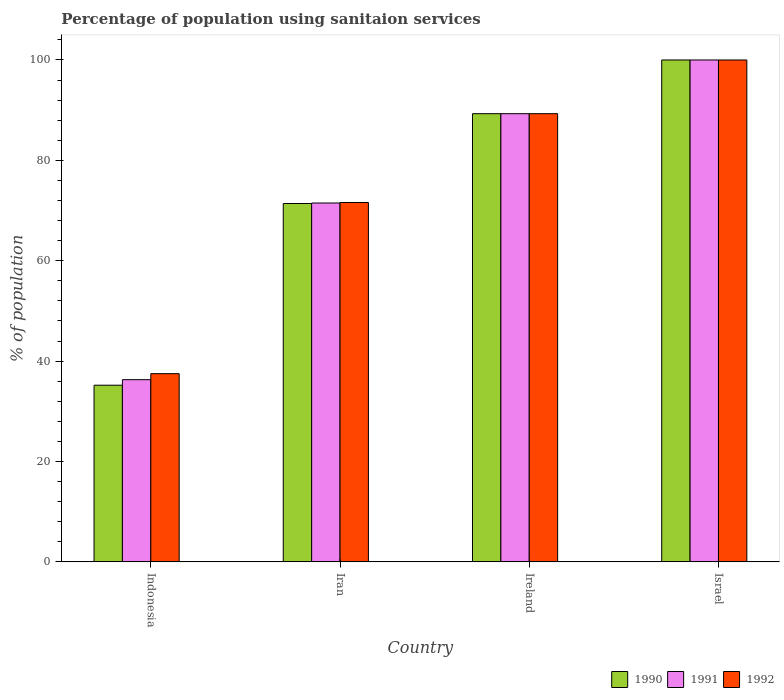How many groups of bars are there?
Offer a terse response. 4. Are the number of bars on each tick of the X-axis equal?
Keep it short and to the point. Yes. What is the label of the 3rd group of bars from the left?
Offer a very short reply. Ireland. What is the percentage of population using sanitaion services in 1992 in Iran?
Give a very brief answer. 71.6. Across all countries, what is the maximum percentage of population using sanitaion services in 1992?
Your answer should be very brief. 100. Across all countries, what is the minimum percentage of population using sanitaion services in 1991?
Provide a short and direct response. 36.3. In which country was the percentage of population using sanitaion services in 1990 minimum?
Provide a succinct answer. Indonesia. What is the total percentage of population using sanitaion services in 1990 in the graph?
Your response must be concise. 295.9. What is the difference between the percentage of population using sanitaion services in 1990 in Iran and that in Ireland?
Offer a terse response. -17.9. What is the difference between the percentage of population using sanitaion services in 1990 in Iran and the percentage of population using sanitaion services in 1991 in Israel?
Provide a short and direct response. -28.6. What is the average percentage of population using sanitaion services in 1992 per country?
Offer a terse response. 74.6. In how many countries, is the percentage of population using sanitaion services in 1992 greater than 36 %?
Offer a very short reply. 4. What is the ratio of the percentage of population using sanitaion services in 1991 in Ireland to that in Israel?
Provide a succinct answer. 0.89. Is the percentage of population using sanitaion services in 1991 in Ireland less than that in Israel?
Your answer should be compact. Yes. What is the difference between the highest and the second highest percentage of population using sanitaion services in 1992?
Your answer should be compact. -10.7. What is the difference between the highest and the lowest percentage of population using sanitaion services in 1992?
Make the answer very short. 62.5. Is the sum of the percentage of population using sanitaion services in 1990 in Indonesia and Israel greater than the maximum percentage of population using sanitaion services in 1992 across all countries?
Give a very brief answer. Yes. What does the 2nd bar from the left in Ireland represents?
Provide a short and direct response. 1991. What does the 3rd bar from the right in Iran represents?
Your response must be concise. 1990. How many bars are there?
Your answer should be very brief. 12. Are the values on the major ticks of Y-axis written in scientific E-notation?
Make the answer very short. No. Does the graph contain any zero values?
Provide a succinct answer. No. Does the graph contain grids?
Keep it short and to the point. No. Where does the legend appear in the graph?
Ensure brevity in your answer.  Bottom right. How many legend labels are there?
Make the answer very short. 3. What is the title of the graph?
Provide a short and direct response. Percentage of population using sanitaion services. What is the label or title of the Y-axis?
Give a very brief answer. % of population. What is the % of population of 1990 in Indonesia?
Keep it short and to the point. 35.2. What is the % of population in 1991 in Indonesia?
Provide a succinct answer. 36.3. What is the % of population of 1992 in Indonesia?
Provide a short and direct response. 37.5. What is the % of population of 1990 in Iran?
Your answer should be compact. 71.4. What is the % of population in 1991 in Iran?
Ensure brevity in your answer.  71.5. What is the % of population in 1992 in Iran?
Your response must be concise. 71.6. What is the % of population in 1990 in Ireland?
Offer a very short reply. 89.3. What is the % of population of 1991 in Ireland?
Make the answer very short. 89.3. What is the % of population of 1992 in Ireland?
Keep it short and to the point. 89.3. What is the % of population of 1992 in Israel?
Ensure brevity in your answer.  100. Across all countries, what is the minimum % of population in 1990?
Provide a short and direct response. 35.2. Across all countries, what is the minimum % of population in 1991?
Provide a short and direct response. 36.3. Across all countries, what is the minimum % of population of 1992?
Ensure brevity in your answer.  37.5. What is the total % of population of 1990 in the graph?
Your answer should be very brief. 295.9. What is the total % of population in 1991 in the graph?
Ensure brevity in your answer.  297.1. What is the total % of population in 1992 in the graph?
Give a very brief answer. 298.4. What is the difference between the % of population of 1990 in Indonesia and that in Iran?
Ensure brevity in your answer.  -36.2. What is the difference between the % of population in 1991 in Indonesia and that in Iran?
Make the answer very short. -35.2. What is the difference between the % of population in 1992 in Indonesia and that in Iran?
Your answer should be compact. -34.1. What is the difference between the % of population of 1990 in Indonesia and that in Ireland?
Provide a succinct answer. -54.1. What is the difference between the % of population of 1991 in Indonesia and that in Ireland?
Ensure brevity in your answer.  -53. What is the difference between the % of population in 1992 in Indonesia and that in Ireland?
Give a very brief answer. -51.8. What is the difference between the % of population in 1990 in Indonesia and that in Israel?
Your response must be concise. -64.8. What is the difference between the % of population in 1991 in Indonesia and that in Israel?
Give a very brief answer. -63.7. What is the difference between the % of population in 1992 in Indonesia and that in Israel?
Keep it short and to the point. -62.5. What is the difference between the % of population of 1990 in Iran and that in Ireland?
Make the answer very short. -17.9. What is the difference between the % of population of 1991 in Iran and that in Ireland?
Give a very brief answer. -17.8. What is the difference between the % of population in 1992 in Iran and that in Ireland?
Ensure brevity in your answer.  -17.7. What is the difference between the % of population in 1990 in Iran and that in Israel?
Ensure brevity in your answer.  -28.6. What is the difference between the % of population of 1991 in Iran and that in Israel?
Provide a succinct answer. -28.5. What is the difference between the % of population in 1992 in Iran and that in Israel?
Provide a short and direct response. -28.4. What is the difference between the % of population of 1990 in Indonesia and the % of population of 1991 in Iran?
Give a very brief answer. -36.3. What is the difference between the % of population in 1990 in Indonesia and the % of population in 1992 in Iran?
Keep it short and to the point. -36.4. What is the difference between the % of population in 1991 in Indonesia and the % of population in 1992 in Iran?
Provide a short and direct response. -35.3. What is the difference between the % of population of 1990 in Indonesia and the % of population of 1991 in Ireland?
Offer a terse response. -54.1. What is the difference between the % of population of 1990 in Indonesia and the % of population of 1992 in Ireland?
Provide a short and direct response. -54.1. What is the difference between the % of population of 1991 in Indonesia and the % of population of 1992 in Ireland?
Keep it short and to the point. -53. What is the difference between the % of population of 1990 in Indonesia and the % of population of 1991 in Israel?
Offer a very short reply. -64.8. What is the difference between the % of population in 1990 in Indonesia and the % of population in 1992 in Israel?
Provide a short and direct response. -64.8. What is the difference between the % of population in 1991 in Indonesia and the % of population in 1992 in Israel?
Your answer should be compact. -63.7. What is the difference between the % of population of 1990 in Iran and the % of population of 1991 in Ireland?
Your response must be concise. -17.9. What is the difference between the % of population in 1990 in Iran and the % of population in 1992 in Ireland?
Ensure brevity in your answer.  -17.9. What is the difference between the % of population of 1991 in Iran and the % of population of 1992 in Ireland?
Your response must be concise. -17.8. What is the difference between the % of population of 1990 in Iran and the % of population of 1991 in Israel?
Provide a short and direct response. -28.6. What is the difference between the % of population in 1990 in Iran and the % of population in 1992 in Israel?
Your answer should be very brief. -28.6. What is the difference between the % of population in 1991 in Iran and the % of population in 1992 in Israel?
Keep it short and to the point. -28.5. What is the difference between the % of population of 1991 in Ireland and the % of population of 1992 in Israel?
Ensure brevity in your answer.  -10.7. What is the average % of population of 1990 per country?
Offer a very short reply. 73.97. What is the average % of population of 1991 per country?
Ensure brevity in your answer.  74.28. What is the average % of population of 1992 per country?
Ensure brevity in your answer.  74.6. What is the difference between the % of population in 1991 and % of population in 1992 in Indonesia?
Keep it short and to the point. -1.2. What is the difference between the % of population in 1990 and % of population in 1991 in Iran?
Provide a short and direct response. -0.1. What is the difference between the % of population in 1990 and % of population in 1992 in Iran?
Offer a terse response. -0.2. What is the difference between the % of population of 1990 and % of population of 1991 in Ireland?
Your answer should be compact. 0. What is the difference between the % of population of 1991 and % of population of 1992 in Ireland?
Ensure brevity in your answer.  0. What is the difference between the % of population of 1990 and % of population of 1991 in Israel?
Give a very brief answer. 0. What is the difference between the % of population in 1991 and % of population in 1992 in Israel?
Ensure brevity in your answer.  0. What is the ratio of the % of population in 1990 in Indonesia to that in Iran?
Your answer should be compact. 0.49. What is the ratio of the % of population of 1991 in Indonesia to that in Iran?
Offer a very short reply. 0.51. What is the ratio of the % of population in 1992 in Indonesia to that in Iran?
Offer a very short reply. 0.52. What is the ratio of the % of population in 1990 in Indonesia to that in Ireland?
Keep it short and to the point. 0.39. What is the ratio of the % of population of 1991 in Indonesia to that in Ireland?
Provide a short and direct response. 0.41. What is the ratio of the % of population in 1992 in Indonesia to that in Ireland?
Offer a terse response. 0.42. What is the ratio of the % of population in 1990 in Indonesia to that in Israel?
Offer a very short reply. 0.35. What is the ratio of the % of population in 1991 in Indonesia to that in Israel?
Offer a terse response. 0.36. What is the ratio of the % of population of 1990 in Iran to that in Ireland?
Your response must be concise. 0.8. What is the ratio of the % of population in 1991 in Iran to that in Ireland?
Your answer should be very brief. 0.8. What is the ratio of the % of population of 1992 in Iran to that in Ireland?
Offer a terse response. 0.8. What is the ratio of the % of population in 1990 in Iran to that in Israel?
Keep it short and to the point. 0.71. What is the ratio of the % of population in 1991 in Iran to that in Israel?
Offer a terse response. 0.71. What is the ratio of the % of population in 1992 in Iran to that in Israel?
Provide a succinct answer. 0.72. What is the ratio of the % of population of 1990 in Ireland to that in Israel?
Keep it short and to the point. 0.89. What is the ratio of the % of population of 1991 in Ireland to that in Israel?
Keep it short and to the point. 0.89. What is the ratio of the % of population of 1992 in Ireland to that in Israel?
Your response must be concise. 0.89. What is the difference between the highest and the second highest % of population in 1992?
Your answer should be very brief. 10.7. What is the difference between the highest and the lowest % of population in 1990?
Ensure brevity in your answer.  64.8. What is the difference between the highest and the lowest % of population in 1991?
Offer a terse response. 63.7. What is the difference between the highest and the lowest % of population of 1992?
Your answer should be compact. 62.5. 